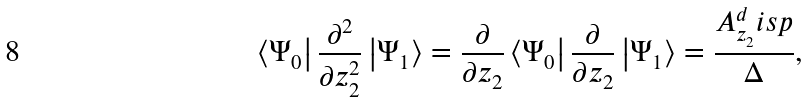Convert formula to latex. <formula><loc_0><loc_0><loc_500><loc_500>\left \langle \Psi _ { 0 } \right | \frac { \partial ^ { 2 } } { \partial z _ { 2 } ^ { 2 } } \left | \Psi _ { 1 } \right \rangle = \frac { \partial } { \partial z _ { 2 } } \left \langle \Psi _ { 0 } \right | \frac { \partial } { \partial z _ { 2 } } \left | \Psi _ { 1 } \right \rangle = \frac { A _ { z _ { 2 } } ^ { d } i s p } { \Delta } ,</formula> 